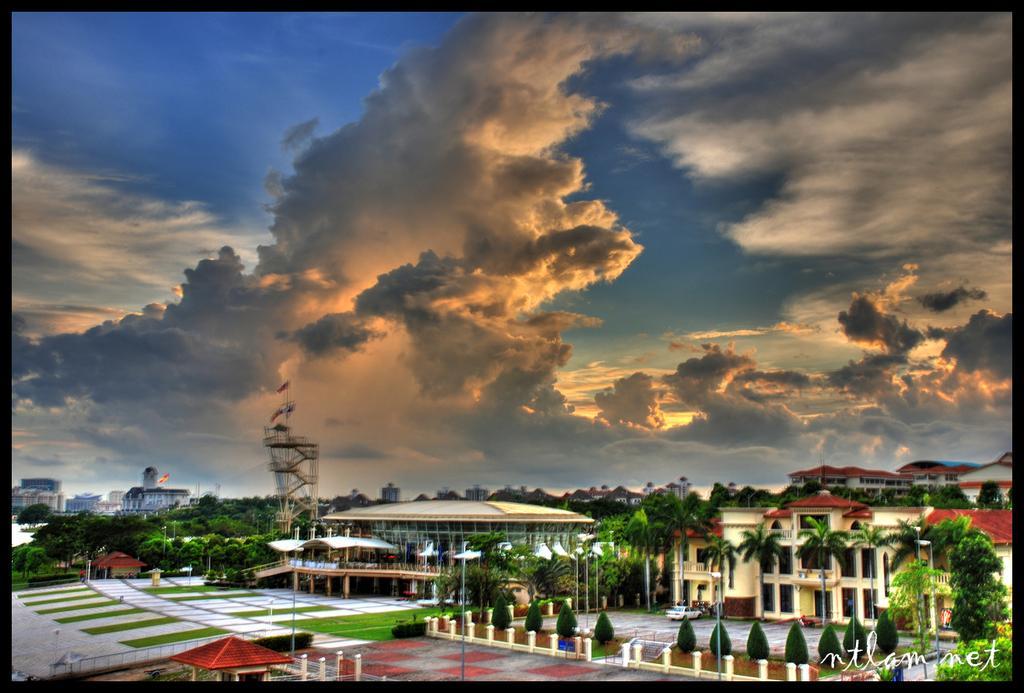Describe this image in one or two sentences. In this image we can see some buildings, houses, trees and at the top of the image there is sunny sky. 